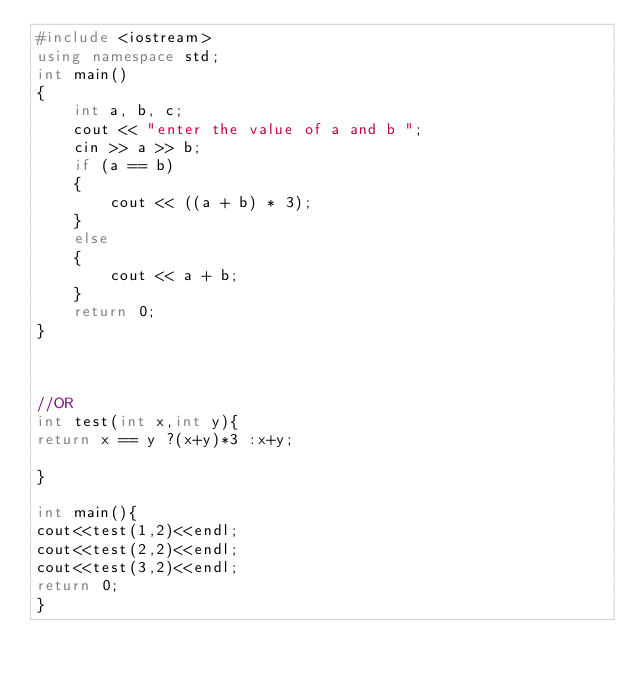<code> <loc_0><loc_0><loc_500><loc_500><_C++_>#include <iostream>
using namespace std;
int main()
{
    int a, b, c;
    cout << "enter the value of a and b ";
    cin >> a >> b;
    if (a == b)
    {
        cout << ((a + b) * 3);
    }
    else
    {
        cout << a + b;
    }
    return 0;
}



//OR
int test(int x,int y){
return x == y ?(x+y)*3 :x+y;

}

int main(){
cout<<test(1,2)<<endl;
cout<<test(2,2)<<endl;
cout<<test(3,2)<<endl;
return 0;
}
</code> 